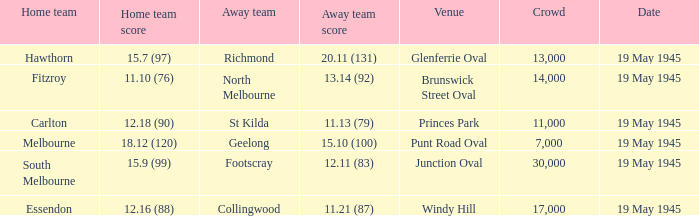On which date was a game played at Junction Oval? 19 May 1945. 